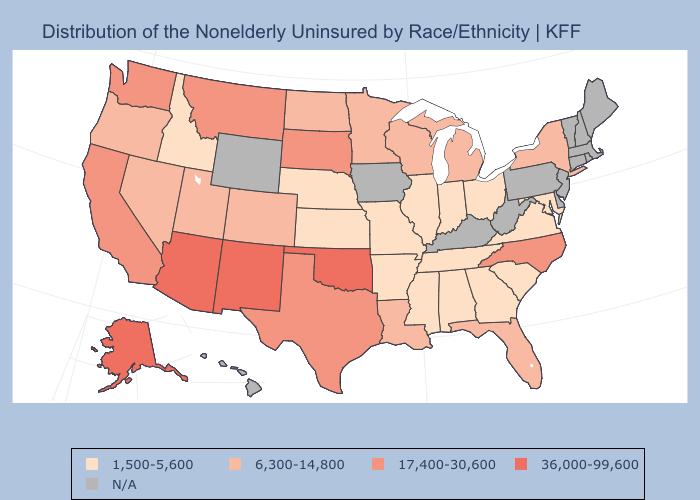Among the states that border New Jersey , which have the lowest value?
Quick response, please. New York. Which states have the lowest value in the USA?
Short answer required. Alabama, Arkansas, Georgia, Idaho, Illinois, Indiana, Kansas, Maryland, Mississippi, Missouri, Nebraska, Ohio, South Carolina, Tennessee, Virginia. Name the states that have a value in the range 17,400-30,600?
Give a very brief answer. California, Montana, North Carolina, South Dakota, Texas, Washington. Name the states that have a value in the range 17,400-30,600?
Answer briefly. California, Montana, North Carolina, South Dakota, Texas, Washington. What is the highest value in the South ?
Quick response, please. 36,000-99,600. Among the states that border Kansas , does Oklahoma have the lowest value?
Answer briefly. No. What is the lowest value in the USA?
Quick response, please. 1,500-5,600. What is the lowest value in states that border Oklahoma?
Concise answer only. 1,500-5,600. Name the states that have a value in the range 1,500-5,600?
Keep it brief. Alabama, Arkansas, Georgia, Idaho, Illinois, Indiana, Kansas, Maryland, Mississippi, Missouri, Nebraska, Ohio, South Carolina, Tennessee, Virginia. Does the first symbol in the legend represent the smallest category?
Write a very short answer. Yes. What is the highest value in states that border Washington?
Concise answer only. 6,300-14,800. What is the value of Washington?
Keep it brief. 17,400-30,600. How many symbols are there in the legend?
Answer briefly. 5. What is the lowest value in the USA?
Concise answer only. 1,500-5,600. 